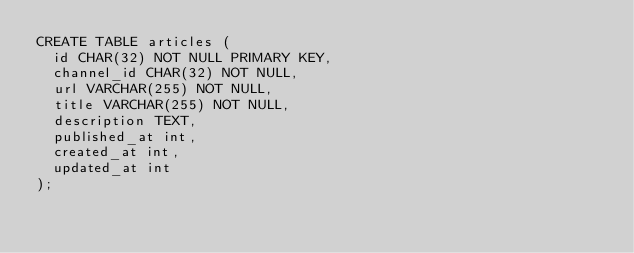Convert code to text. <code><loc_0><loc_0><loc_500><loc_500><_SQL_>CREATE TABLE articles (
  id CHAR(32) NOT NULL PRIMARY KEY,
  channel_id CHAR(32) NOT NULL,
  url VARCHAR(255) NOT NULL,
  title VARCHAR(255) NOT NULL,
  description TEXT,
  published_at int,
  created_at int,
  updated_at int
);
</code> 